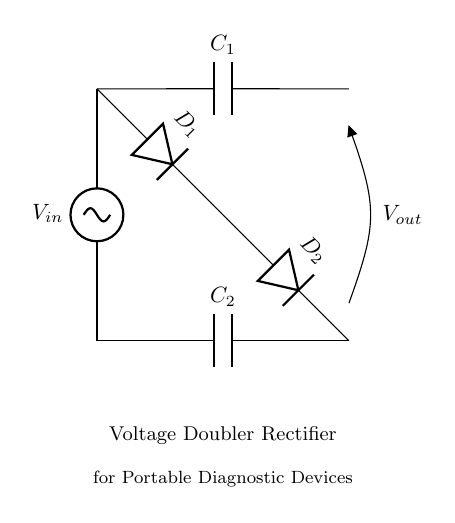What is the input source voltage? The circuit diagram indicates an AC source labeled as \( V_{in} \) at the top left corner. The specific voltage is not provided in the diagram, but it represents the input voltage for the circuit.
Answer: \( V_{in} \) How many capacitors are in the circuit? The diagram shows two components labeled as capacitors, \( C_1 \) and \( C_2 \). They are distinctly marked and located at different positions in the circuit.
Answer: 2 What is the function of this circuit? The diagram is labeled with "Voltage Doubler Rectifier," which indicates the primary function of the circuit to double the input voltage for the output.
Answer: Voltage doubler What are the diode identifiers in the circuit? The circuit includes two diodes, marked as \( D_1 \) and \( D_2 \). These identifiers are clearly shown next to the diode symbols, indicating their respective roles.
Answer: \( D_1, D_2 \) In which direction do current flows through \( D_1 \)? The flow of current through \( D_1 \) can be inferred from the position of the AC source and the output connection. The diode is oriented to allow current from the capacitor to the load during the positive half-cycle of input voltage.
Answer: Forward Which component is responsible for voltage storage? The capacitors \( C_1 \) and \( C_2 \) are responsible for storing voltage in the circuit, as they are connected in a way to charge and hold energy. They are specifically labeled as storage devices.
Answer: Capacitors What does \( V_{out} \) represent in the circuit? The label \( V_{out} \) at the bottom right corner indicates the output voltage, which is the voltage available for further use, after the rectification and doubling processes.
Answer: Output voltage 